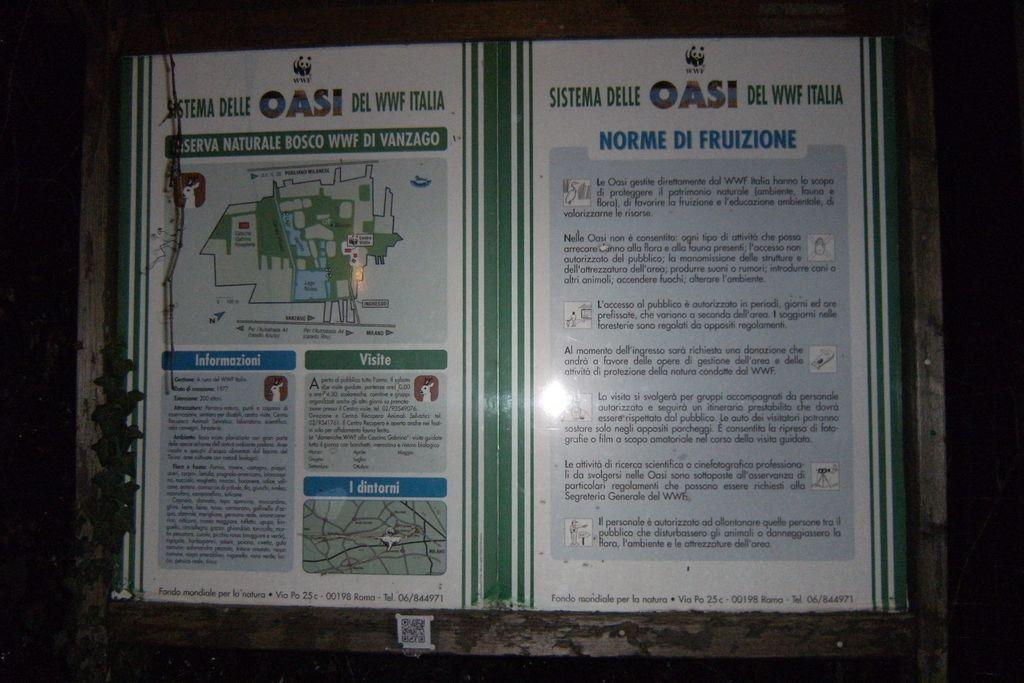<image>
Describe the image concisely. A map is posted for the Oasi del WWF Italia. 